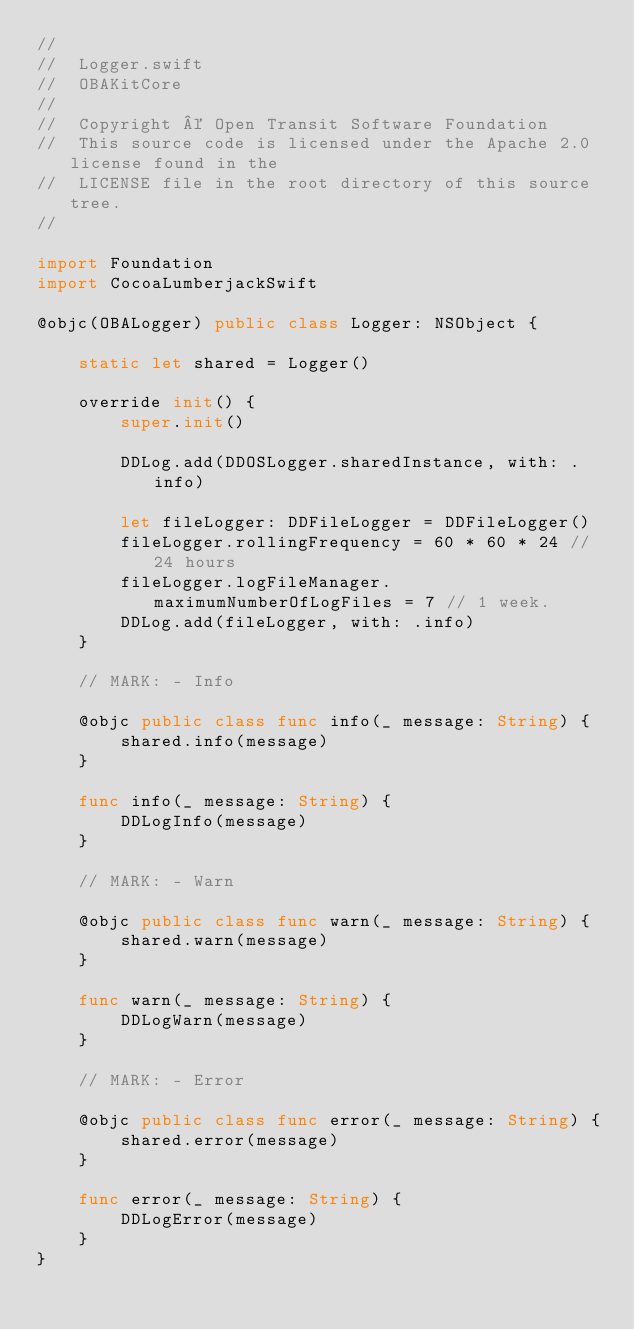<code> <loc_0><loc_0><loc_500><loc_500><_Swift_>//
//  Logger.swift
//  OBAKitCore
//
//  Copyright © Open Transit Software Foundation
//  This source code is licensed under the Apache 2.0 license found in the
//  LICENSE file in the root directory of this source tree.
//

import Foundation
import CocoaLumberjackSwift

@objc(OBALogger) public class Logger: NSObject {

    static let shared = Logger()

    override init() {
        super.init()

        DDLog.add(DDOSLogger.sharedInstance, with: .info)

        let fileLogger: DDFileLogger = DDFileLogger()
        fileLogger.rollingFrequency = 60 * 60 * 24 // 24 hours
        fileLogger.logFileManager.maximumNumberOfLogFiles = 7 // 1 week.
        DDLog.add(fileLogger, with: .info)
    }

    // MARK: - Info

    @objc public class func info(_ message: String) {
        shared.info(message)
    }

    func info(_ message: String) {
        DDLogInfo(message)
    }

    // MARK: - Warn

    @objc public class func warn(_ message: String) {
        shared.warn(message)
    }

    func warn(_ message: String) {
        DDLogWarn(message)
    }

    // MARK: - Error

    @objc public class func error(_ message: String) {
        shared.error(message)
    }

    func error(_ message: String) {
        DDLogError(message)
    }
}
</code> 